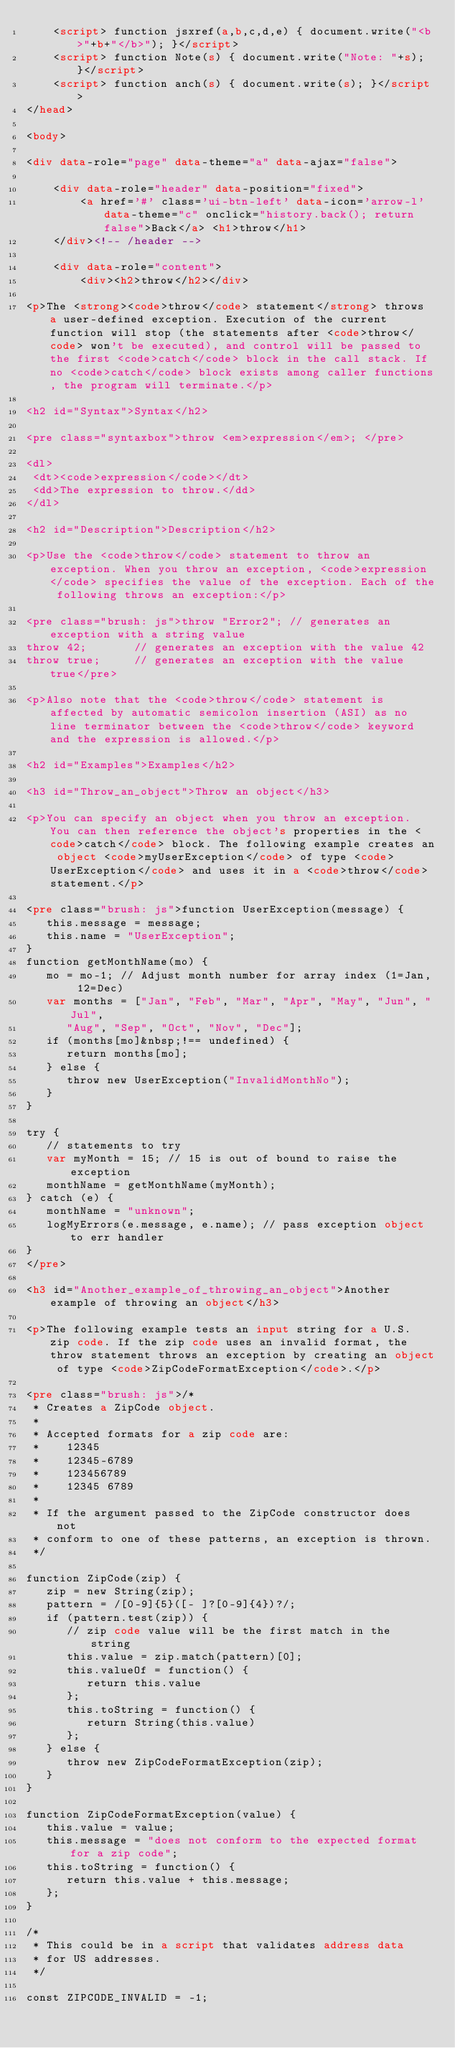Convert code to text. <code><loc_0><loc_0><loc_500><loc_500><_HTML_>	<script> function jsxref(a,b,c,d,e) { document.write("<b>"+b+"</b>"); }</script>
	<script> function Note(s) { document.write("Note: "+s); }</script>
	<script> function anch(s) { document.write(s); }</script>
</head>
 
<body>

<div data-role="page" data-theme="a" data-ajax="false">

	<div data-role="header" data-position="fixed">
		<a href='#' class='ui-btn-left' data-icon='arrow-l' data-theme="c" onclick="history.back(); return false">Back</a> <h1>throw</h1>
	</div><!-- /header -->

	<div data-role="content">
		<div><h2>throw</h2></div>

<p>The <strong><code>throw</code> statement</strong> throws a user-defined exception. Execution of the current function will stop (the statements after <code>throw</code> won't be executed), and control will be passed to the first <code>catch</code> block in the call stack. If no <code>catch</code> block exists among caller functions, the program will terminate.</p>

<h2 id="Syntax">Syntax</h2>

<pre class="syntaxbox">throw <em>expression</em>; </pre>

<dl>
 <dt><code>expression</code></dt>
 <dd>The expression to throw.</dd>
</dl>

<h2 id="Description">Description</h2>

<p>Use the <code>throw</code> statement to throw an exception. When you throw an exception, <code>expression</code> specifies the value of the exception. Each of the following throws an exception:</p>

<pre class="brush: js">throw "Error2"; // generates an exception with a string value
throw 42;       // generates an exception with the value 42
throw true;     // generates an exception with the value true</pre>

<p>Also note that the <code>throw</code> statement is affected by automatic semicolon insertion (ASI) as no line terminator between the <code>throw</code> keyword and the expression is allowed.</p>

<h2 id="Examples">Examples</h2>

<h3 id="Throw_an_object">Throw an object</h3>

<p>You can specify an object when you throw an exception. You can then reference the object's properties in the <code>catch</code> block. The following example creates an object <code>myUserException</code> of type <code>UserException</code> and uses it in a <code>throw</code> statement.</p>

<pre class="brush: js">function UserException(message) {
   this.message = message;
   this.name = "UserException";
}
function getMonthName(mo) {
   mo = mo-1; // Adjust month number for array index (1=Jan, 12=Dec)
   var months = ["Jan", "Feb", "Mar", "Apr", "May", "Jun", "Jul",
      "Aug", "Sep", "Oct", "Nov", "Dec"];
   if (months[mo]&nbsp;!== undefined) {
      return months[mo];
   } else {
      throw new UserException("InvalidMonthNo");
   }
}

try {
   // statements to try
   var myMonth = 15; // 15 is out of bound to raise the exception
   monthName = getMonthName(myMonth);
} catch (e) {
   monthName = "unknown";
   logMyErrors(e.message, e.name); // pass exception object to err handler
}
</pre>

<h3 id="Another_example_of_throwing_an_object">Another example of throwing an object</h3>

<p>The following example tests an input string for a U.S. zip code. If the zip code uses an invalid format, the throw statement throws an exception by creating an object of type <code>ZipCodeFormatException</code>.</p>

<pre class="brush: js">/*
 * Creates a ZipCode object.
 *
 * Accepted formats for a zip code are:
 *    12345
 *    12345-6789
 *    123456789
 *    12345 6789
 *
 * If the argument passed to the ZipCode constructor does not
 * conform to one of these patterns, an exception is thrown.
 */

function ZipCode(zip) {
   zip = new String(zip);
   pattern = /[0-9]{5}([- ]?[0-9]{4})?/;
   if (pattern.test(zip)) {
      // zip code value will be the first match in the string
      this.value = zip.match(pattern)[0];
      this.valueOf = function() {
         return this.value
      };
      this.toString = function() {
         return String(this.value)
      };
   } else {
      throw new ZipCodeFormatException(zip);
   }
}

function ZipCodeFormatException(value) {
   this.value = value;
   this.message = "does not conform to the expected format for a zip code";
   this.toString = function() {
      return this.value + this.message;
   };
}

/*
 * This could be in a script that validates address data
 * for US addresses.
 */

const ZIPCODE_INVALID = -1;</code> 